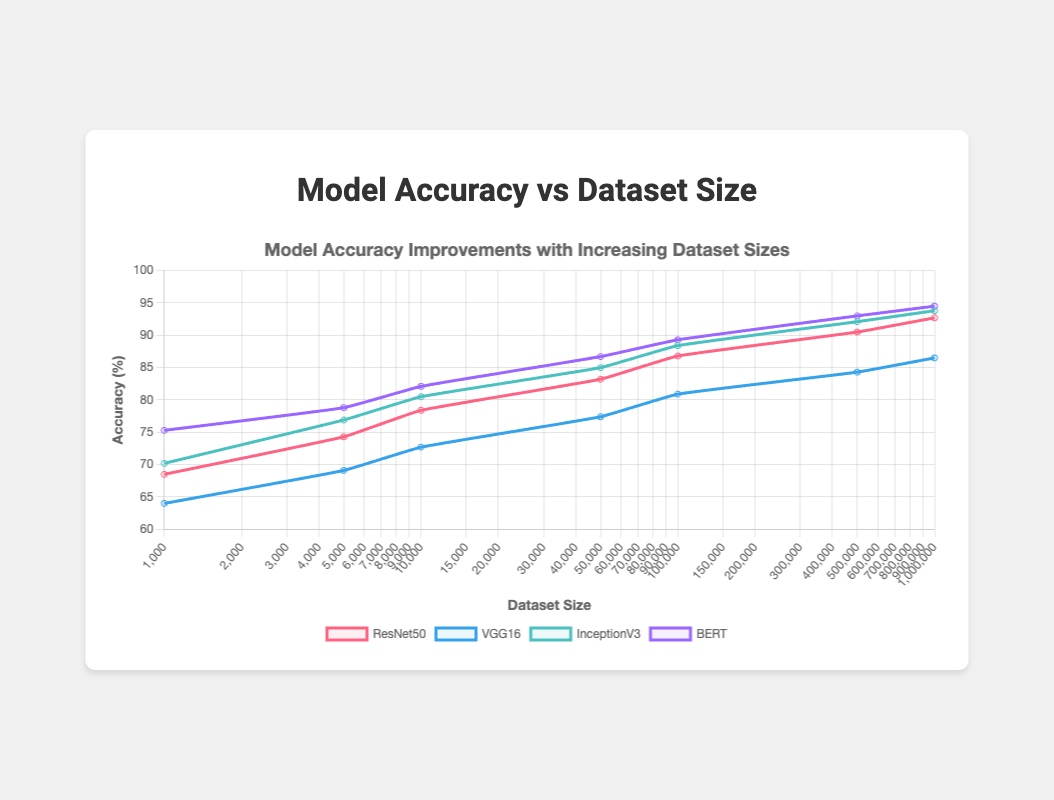What is the accuracy difference between ResNet50 and VGG16 when the dataset size is 10,000? Look at the accuracy values for ResNet50 and VGG16 at a dataset size of 10,000. Subtract the accuracy of VGG16 from that of ResNet50: 78.4 - 72.7 = 5.7
Answer: 5.7 Which model shows the highest accuracy improvement from 1,000 to 1,000,000 dataset size? Calculate the accuracy improvement for each model by subtracting the initial accuracy at 1,000 dataset size from the final accuracy at 1,000,000 dataset size: 
ResNet50: 92.7 - 68.5 = 24.2
VGG16: 86.5 - 64.0 = 22.5
InceptionV3: 93.8 - 70.2 = 23.6
BERT: 94.5 - 75.3 = 19.2. 
ResNet50 has the highest improvement of 24.2
Answer: ResNet50 What is the average accuracy of ResNet50 for dataset sizes of 5,000, 50,000, and 500,000? Add the accuracy values of ResNet50 for the specified dataset sizes and divide by 3: (74.3 + 83.2 + 90.5) / 3 = 82.67
Answer: 82.67 Do all models show a consistent increase in accuracy with increasing dataset sizes? Observe the accuracy values of all models across different dataset sizes. All values increase as dataset size increases, so the pattern is consistent
Answer: Yes Which model achieves the highest accuracy for the smallest dataset size (1,000)? Look at the accuracy values for the dataset size of 1,000 across all models: 
ResNet50: 68.5,
VGG16: 64.0,
InceptionV3: 70.2,
BERT: 75.3. 
BERT has the highest accuracy
Answer: BERT How does the accuracy improvement of InceptionV3 compare to the improvement of BERT from 50,000 to 500,000 dataset size? Calculate the accuracy improvement for both models:
InceptionV3: 92.1 - 85.0 = 7.1,
BERT: 93.0 - 86.7 = 6.3. 
InceptionV3's improvement is greater by 0.8
Answer: InceptionV3 improves more by 0.8 What is the ratio of accuracy between BERT and VGG16 at the dataset size of 500,000? Find the accuracy values for both models at 500,000 and divide BERT's accuracy by VGG16's: 93.0 / 84.3 ≈ 1.103
Answer: ~1.103 Which two models have a greater than 10% difference in accuracy for the dataset size 100,000? Calculate the accuracy differences for each pair of models at 100,000 dataset size:
ResNet50 - VGG16: 86.8 - 80.9 = 5.9,
ResNet50 - InceptionV3: 86.8 - 88.4 = -1.6,
ResNet50 - BERT: 86.8 - 89.3 = -2.5,
VGG16 - InceptionV3: 80.9 - 88.4 = -7.5,
VGG16 - BERT: 80.9 - 89.3 = -8.4,
InceptionV3 - BERT: 88.4 - 89.3 = -0.9.
No pair has a greater than 10% difference
Answer: None 